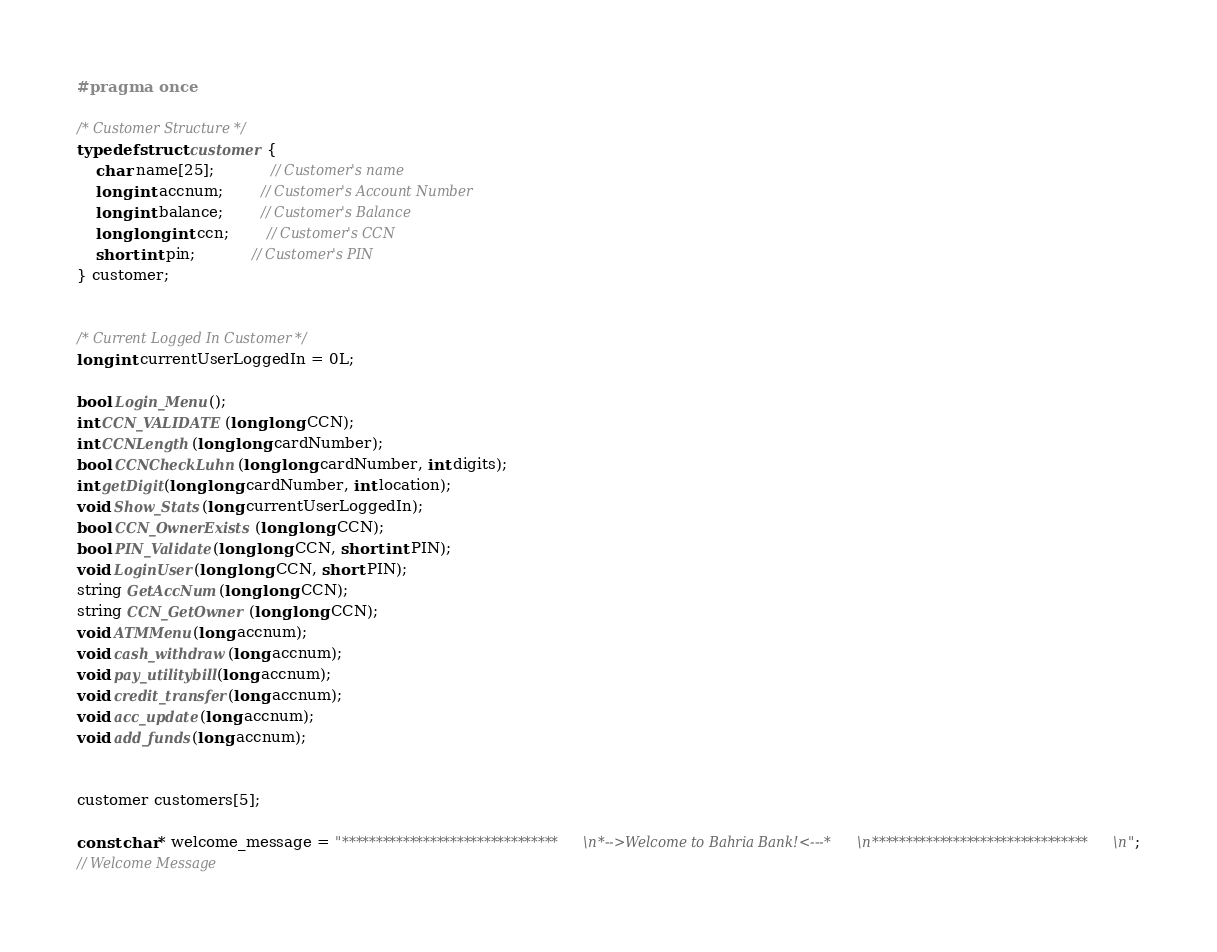Convert code to text. <code><loc_0><loc_0><loc_500><loc_500><_C_>#pragma once

/* Customer Structure */
typedef struct customer {
	char name[25];			// Customer's name
	long int accnum;		// Customer's Account Number
	long int balance;		// Customer's Balance
	long long int ccn;		// Customer's CCN
	short int pin;			// Customer's PIN
} customer;


/* Current Logged In Customer */
long int currentUserLoggedIn = 0L;

bool Login_Menu();
int CCN_VALIDATE(long long CCN);
int CCNLength(long long cardNumber);
bool CCNCheckLuhn(long long cardNumber, int digits);
int getDigit(long long cardNumber, int location);
void Show_Stats(long currentUserLoggedIn);
bool CCN_OwnerExists(long long CCN);
bool PIN_Validate(long long CCN, short int PIN);
void LoginUser(long long CCN, short PIN);
string GetAccNum(long long CCN);
string CCN_GetOwner(long long CCN);
void ATMMenu(long accnum);
void cash_withdraw(long accnum);
void pay_utilitybill(long accnum);
void credit_transfer(long accnum);
void acc_update(long accnum);
void add_funds(long accnum);


customer customers[5];

const char* welcome_message = "********************************\n*-->Welcome to Bahria Bank!<---*\n********************************\n";
// Welcome Message</code> 